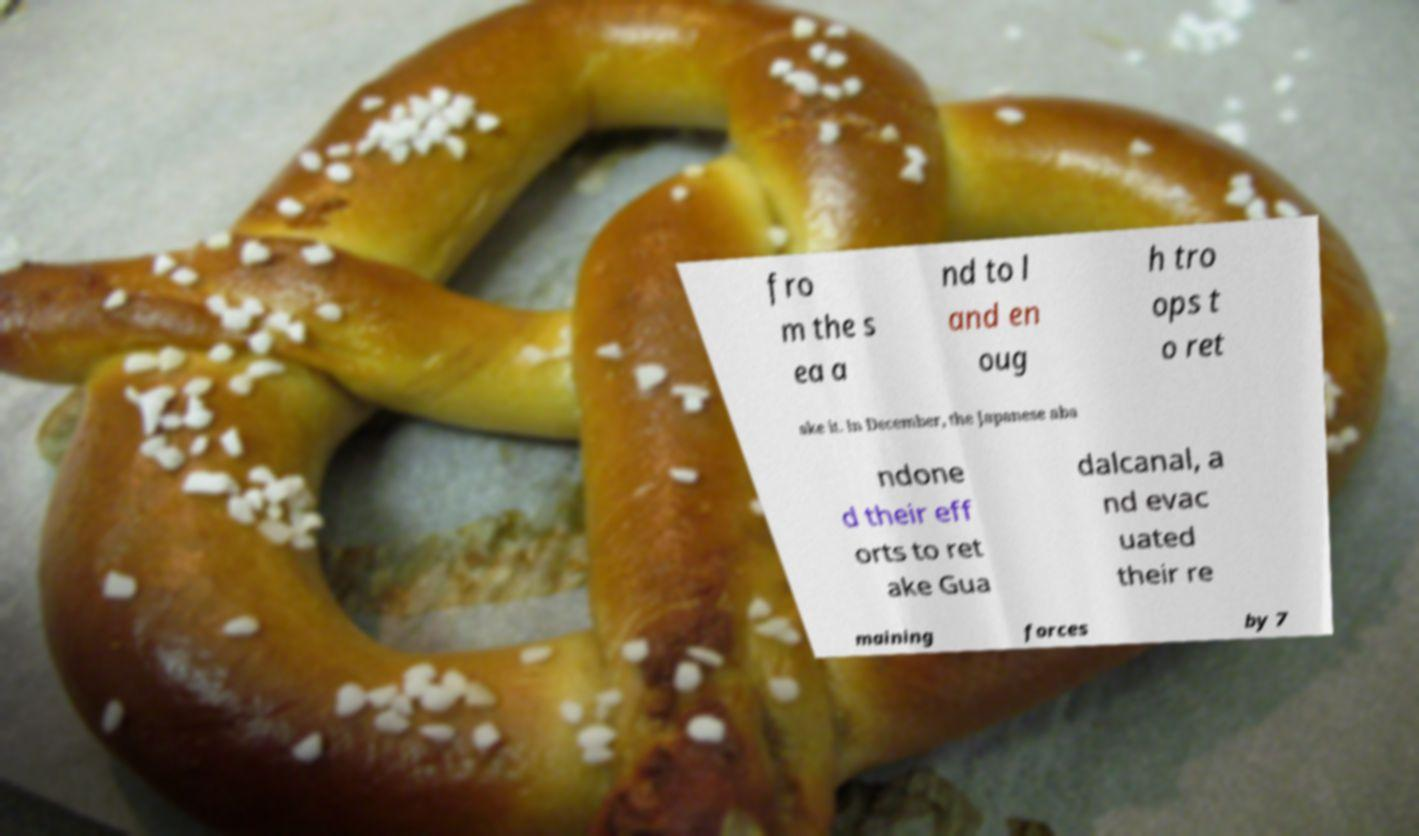Could you extract and type out the text from this image? fro m the s ea a nd to l and en oug h tro ops t o ret ake it. In December, the Japanese aba ndone d their eff orts to ret ake Gua dalcanal, a nd evac uated their re maining forces by 7 